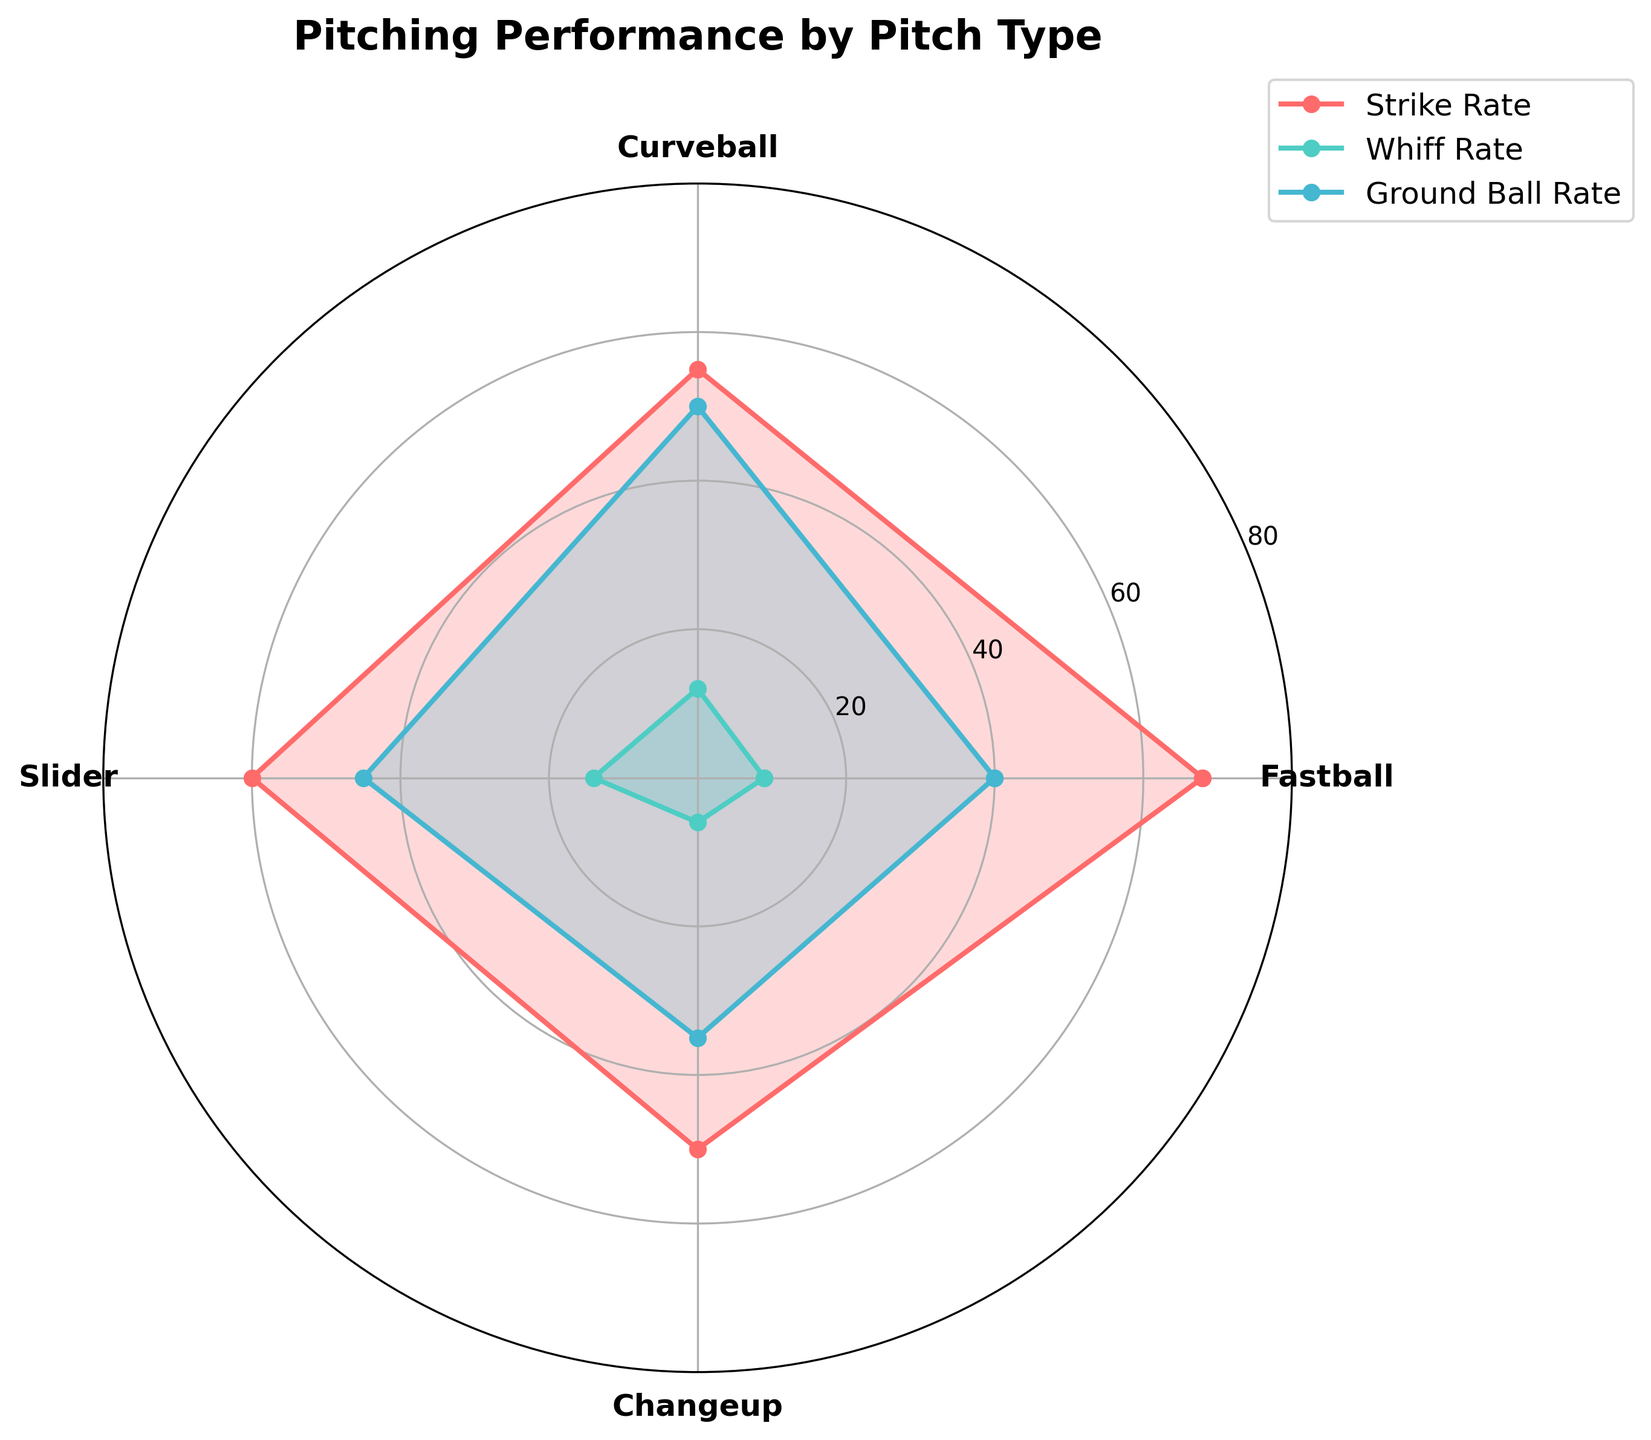What is the title of the plot? The title is usually located at the top of the plot, and it is written in a larger or bolder font to stand out clearly.
Answer: Pitching Performance by Pitch Type How many Pitch Types are displayed in the chart? Count the number of different labels provided on the circular axis, typically near the perimeter of the rose chart.
Answer: 4 Which Pitch Type has the highest Strike Rate? Look at the different plots on the chart and identify which one reaches the highest value on the radial axis for Strike Rate.
Answer: Fastball What's the sum of the Whiff Rates for Curveball and Slider? Identify the Whiff Rates for Curveball and Slider from the plot and add them together.
Answer: Curveball (12) + Slider (14) = 26 Which Pitch Type has a higher Ground Ball Rate, Fastball or Changeup? Compare the positions of the Ground Ball Rate plots for Fastball and Changeup to see which one is higher on the radial axis.
Answer: Fastball Which Pitch Type has the lowest Whiff Rate? Observe the plots and pinpoint the one that has the lowest value on the radial axis for Whiff Rate.
Answer: Changeup Is the Ground Ball Rate for Curveball greater than the Strike Rate for Changeup? Compare the Ground Ball Rate of Curveball with the Strike Rate of Changeup on the chart to determine if one is greater than the other.
Answer: Yes Which category shows the greatest variability among all Pitch Types? Look for the category (Strike Rate, Whiff Rate, Ground Ball Rate) with the widest range of values across different Pitch Types.
Answer: Strike Rate What is the average Strike Rate for all Pitch Types? Sum the Strike Rates for all Pitch Types and divide by the number of Pitch Types.
Answer: (68 + 55 + 60 + 50) / 4 = 233 / 4 = 58.25 Does Slider have a higher Whiff Rate than Ground Ball Rate? Compare the Whiff Rate and Ground Ball Rate for Slider specifically to determine which is higher.
Answer: No 